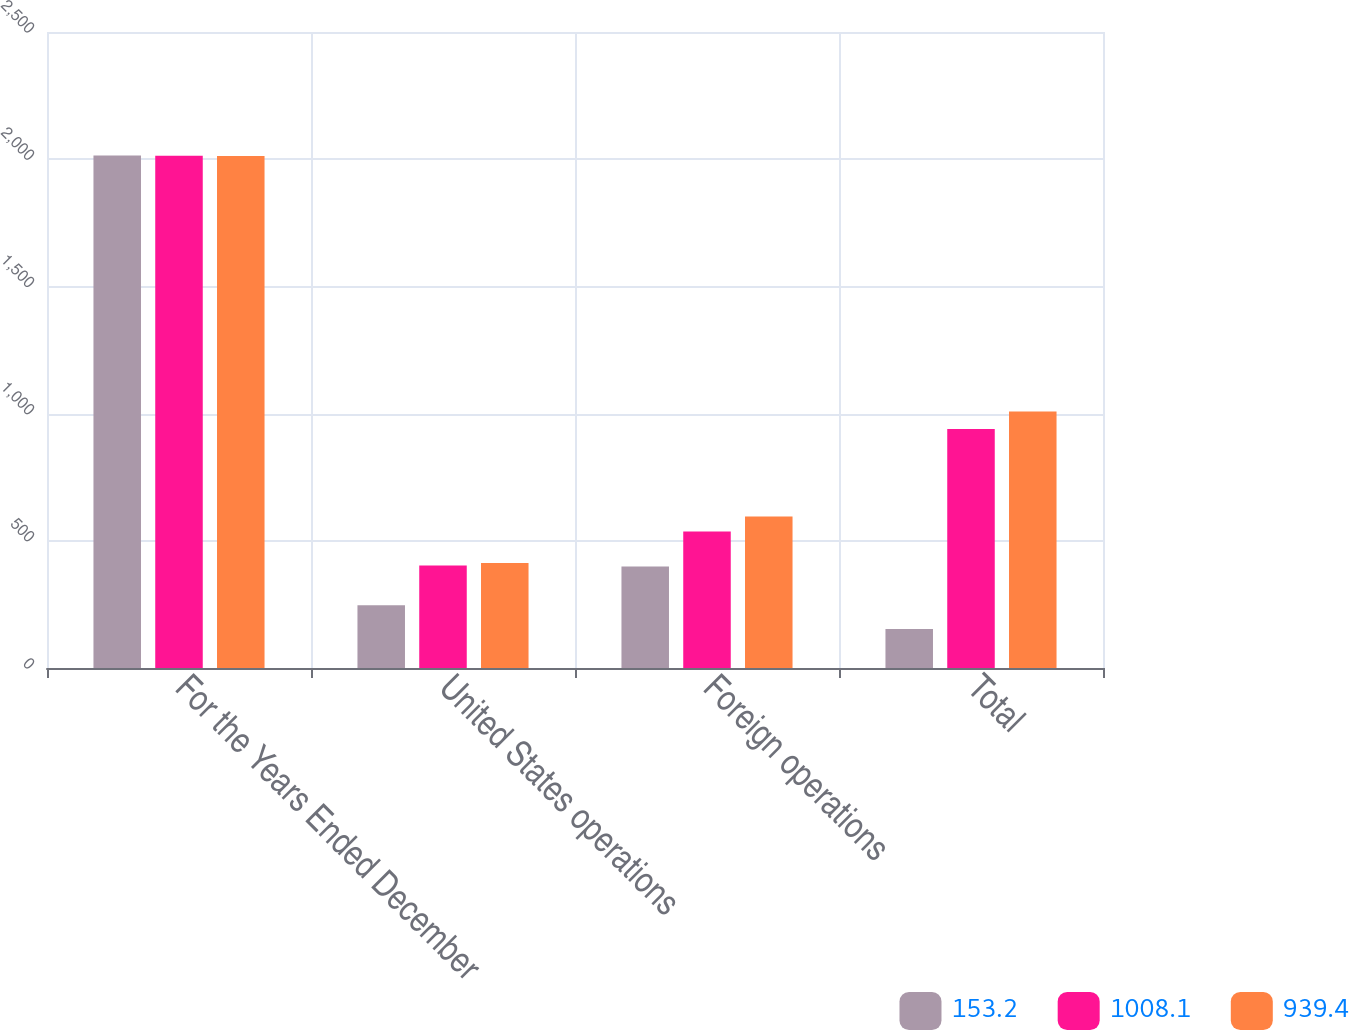Convert chart. <chart><loc_0><loc_0><loc_500><loc_500><stacked_bar_chart><ecel><fcel>For the Years Ended December<fcel>United States operations<fcel>Foreign operations<fcel>Total<nl><fcel>153.2<fcel>2015<fcel>246.2<fcel>399.4<fcel>153.2<nl><fcel>1008.1<fcel>2014<fcel>403.3<fcel>536.1<fcel>939.4<nl><fcel>939.4<fcel>2013<fcel>412.4<fcel>595.7<fcel>1008.1<nl></chart> 